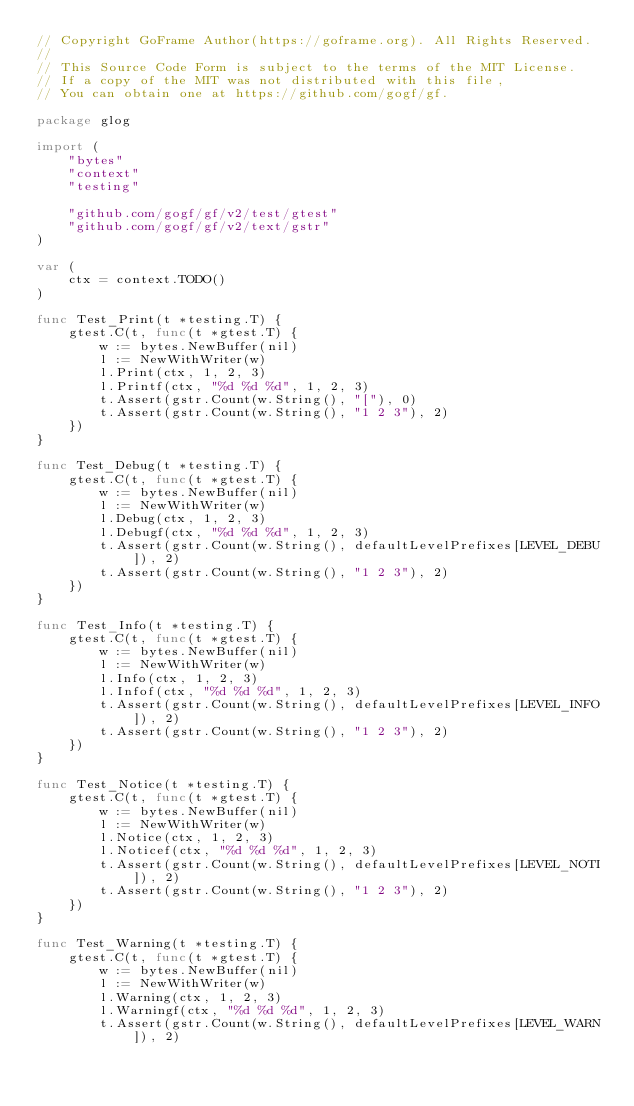Convert code to text. <code><loc_0><loc_0><loc_500><loc_500><_Go_>// Copyright GoFrame Author(https://goframe.org). All Rights Reserved.
//
// This Source Code Form is subject to the terms of the MIT License.
// If a copy of the MIT was not distributed with this file,
// You can obtain one at https://github.com/gogf/gf.

package glog

import (
	"bytes"
	"context"
	"testing"

	"github.com/gogf/gf/v2/test/gtest"
	"github.com/gogf/gf/v2/text/gstr"
)

var (
	ctx = context.TODO()
)

func Test_Print(t *testing.T) {
	gtest.C(t, func(t *gtest.T) {
		w := bytes.NewBuffer(nil)
		l := NewWithWriter(w)
		l.Print(ctx, 1, 2, 3)
		l.Printf(ctx, "%d %d %d", 1, 2, 3)
		t.Assert(gstr.Count(w.String(), "["), 0)
		t.Assert(gstr.Count(w.String(), "1 2 3"), 2)
	})
}

func Test_Debug(t *testing.T) {
	gtest.C(t, func(t *gtest.T) {
		w := bytes.NewBuffer(nil)
		l := NewWithWriter(w)
		l.Debug(ctx, 1, 2, 3)
		l.Debugf(ctx, "%d %d %d", 1, 2, 3)
		t.Assert(gstr.Count(w.String(), defaultLevelPrefixes[LEVEL_DEBU]), 2)
		t.Assert(gstr.Count(w.String(), "1 2 3"), 2)
	})
}

func Test_Info(t *testing.T) {
	gtest.C(t, func(t *gtest.T) {
		w := bytes.NewBuffer(nil)
		l := NewWithWriter(w)
		l.Info(ctx, 1, 2, 3)
		l.Infof(ctx, "%d %d %d", 1, 2, 3)
		t.Assert(gstr.Count(w.String(), defaultLevelPrefixes[LEVEL_INFO]), 2)
		t.Assert(gstr.Count(w.String(), "1 2 3"), 2)
	})
}

func Test_Notice(t *testing.T) {
	gtest.C(t, func(t *gtest.T) {
		w := bytes.NewBuffer(nil)
		l := NewWithWriter(w)
		l.Notice(ctx, 1, 2, 3)
		l.Noticef(ctx, "%d %d %d", 1, 2, 3)
		t.Assert(gstr.Count(w.String(), defaultLevelPrefixes[LEVEL_NOTI]), 2)
		t.Assert(gstr.Count(w.String(), "1 2 3"), 2)
	})
}

func Test_Warning(t *testing.T) {
	gtest.C(t, func(t *gtest.T) {
		w := bytes.NewBuffer(nil)
		l := NewWithWriter(w)
		l.Warning(ctx, 1, 2, 3)
		l.Warningf(ctx, "%d %d %d", 1, 2, 3)
		t.Assert(gstr.Count(w.String(), defaultLevelPrefixes[LEVEL_WARN]), 2)</code> 